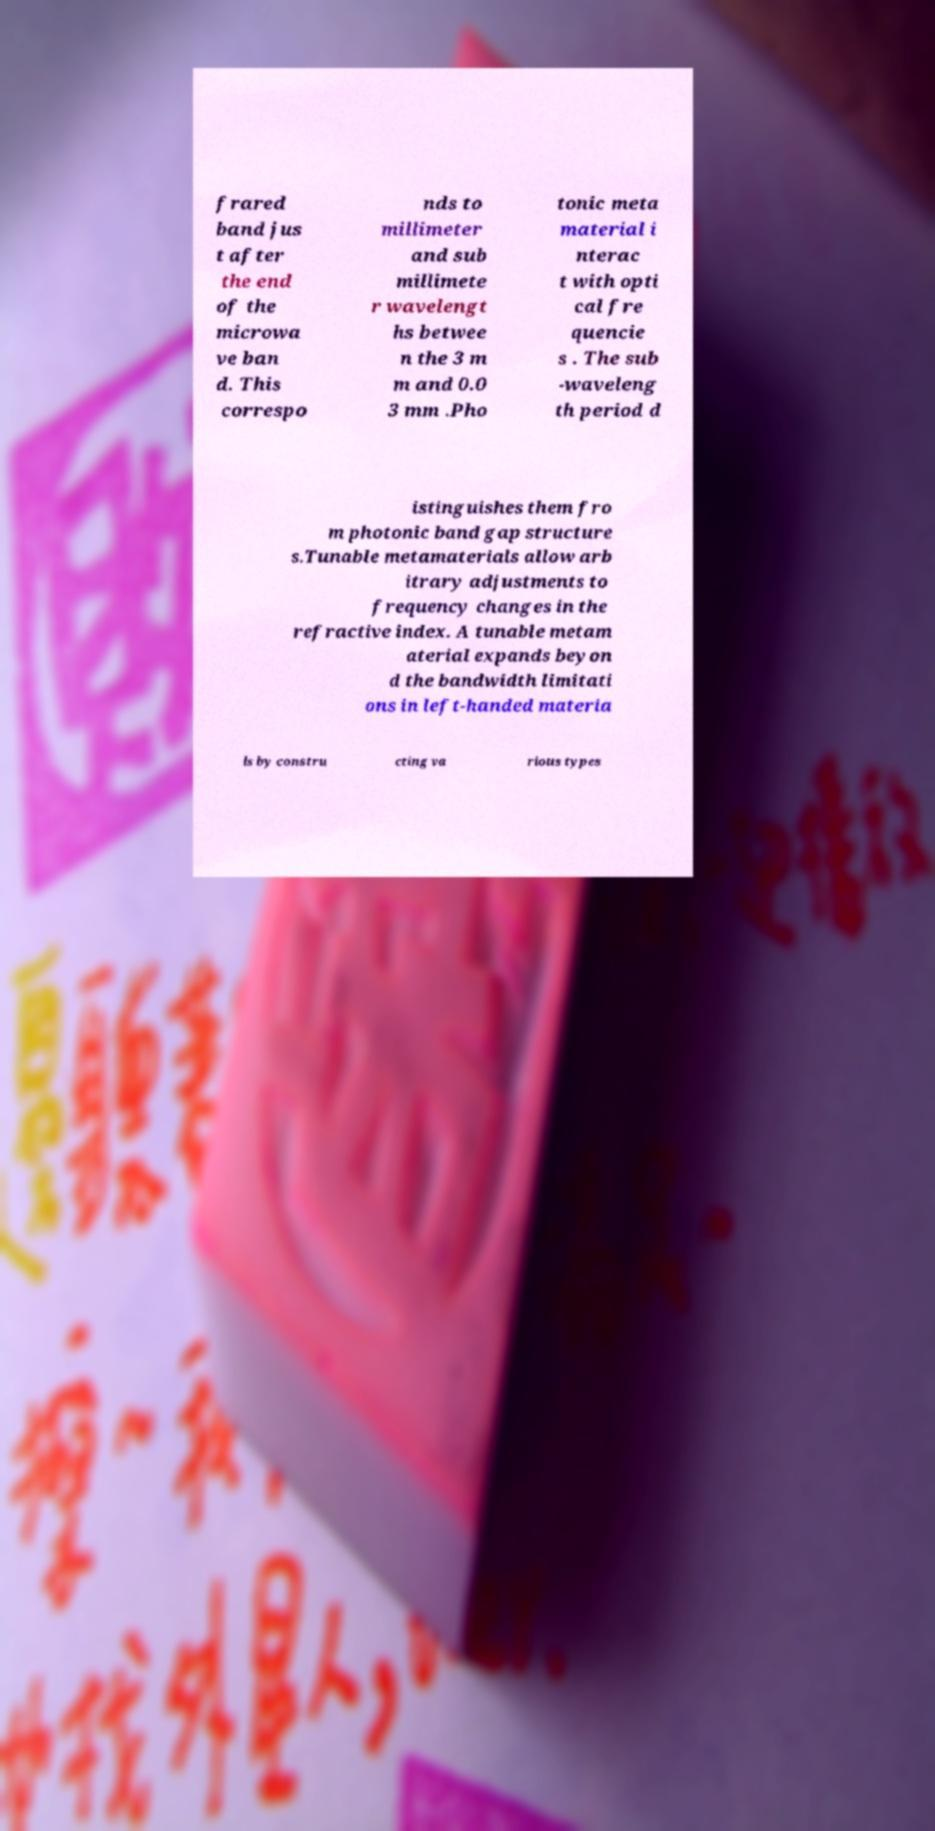Could you extract and type out the text from this image? frared band jus t after the end of the microwa ve ban d. This correspo nds to millimeter and sub millimete r wavelengt hs betwee n the 3 m m and 0.0 3 mm .Pho tonic meta material i nterac t with opti cal fre quencie s . The sub -waveleng th period d istinguishes them fro m photonic band gap structure s.Tunable metamaterials allow arb itrary adjustments to frequency changes in the refractive index. A tunable metam aterial expands beyon d the bandwidth limitati ons in left-handed materia ls by constru cting va rious types 